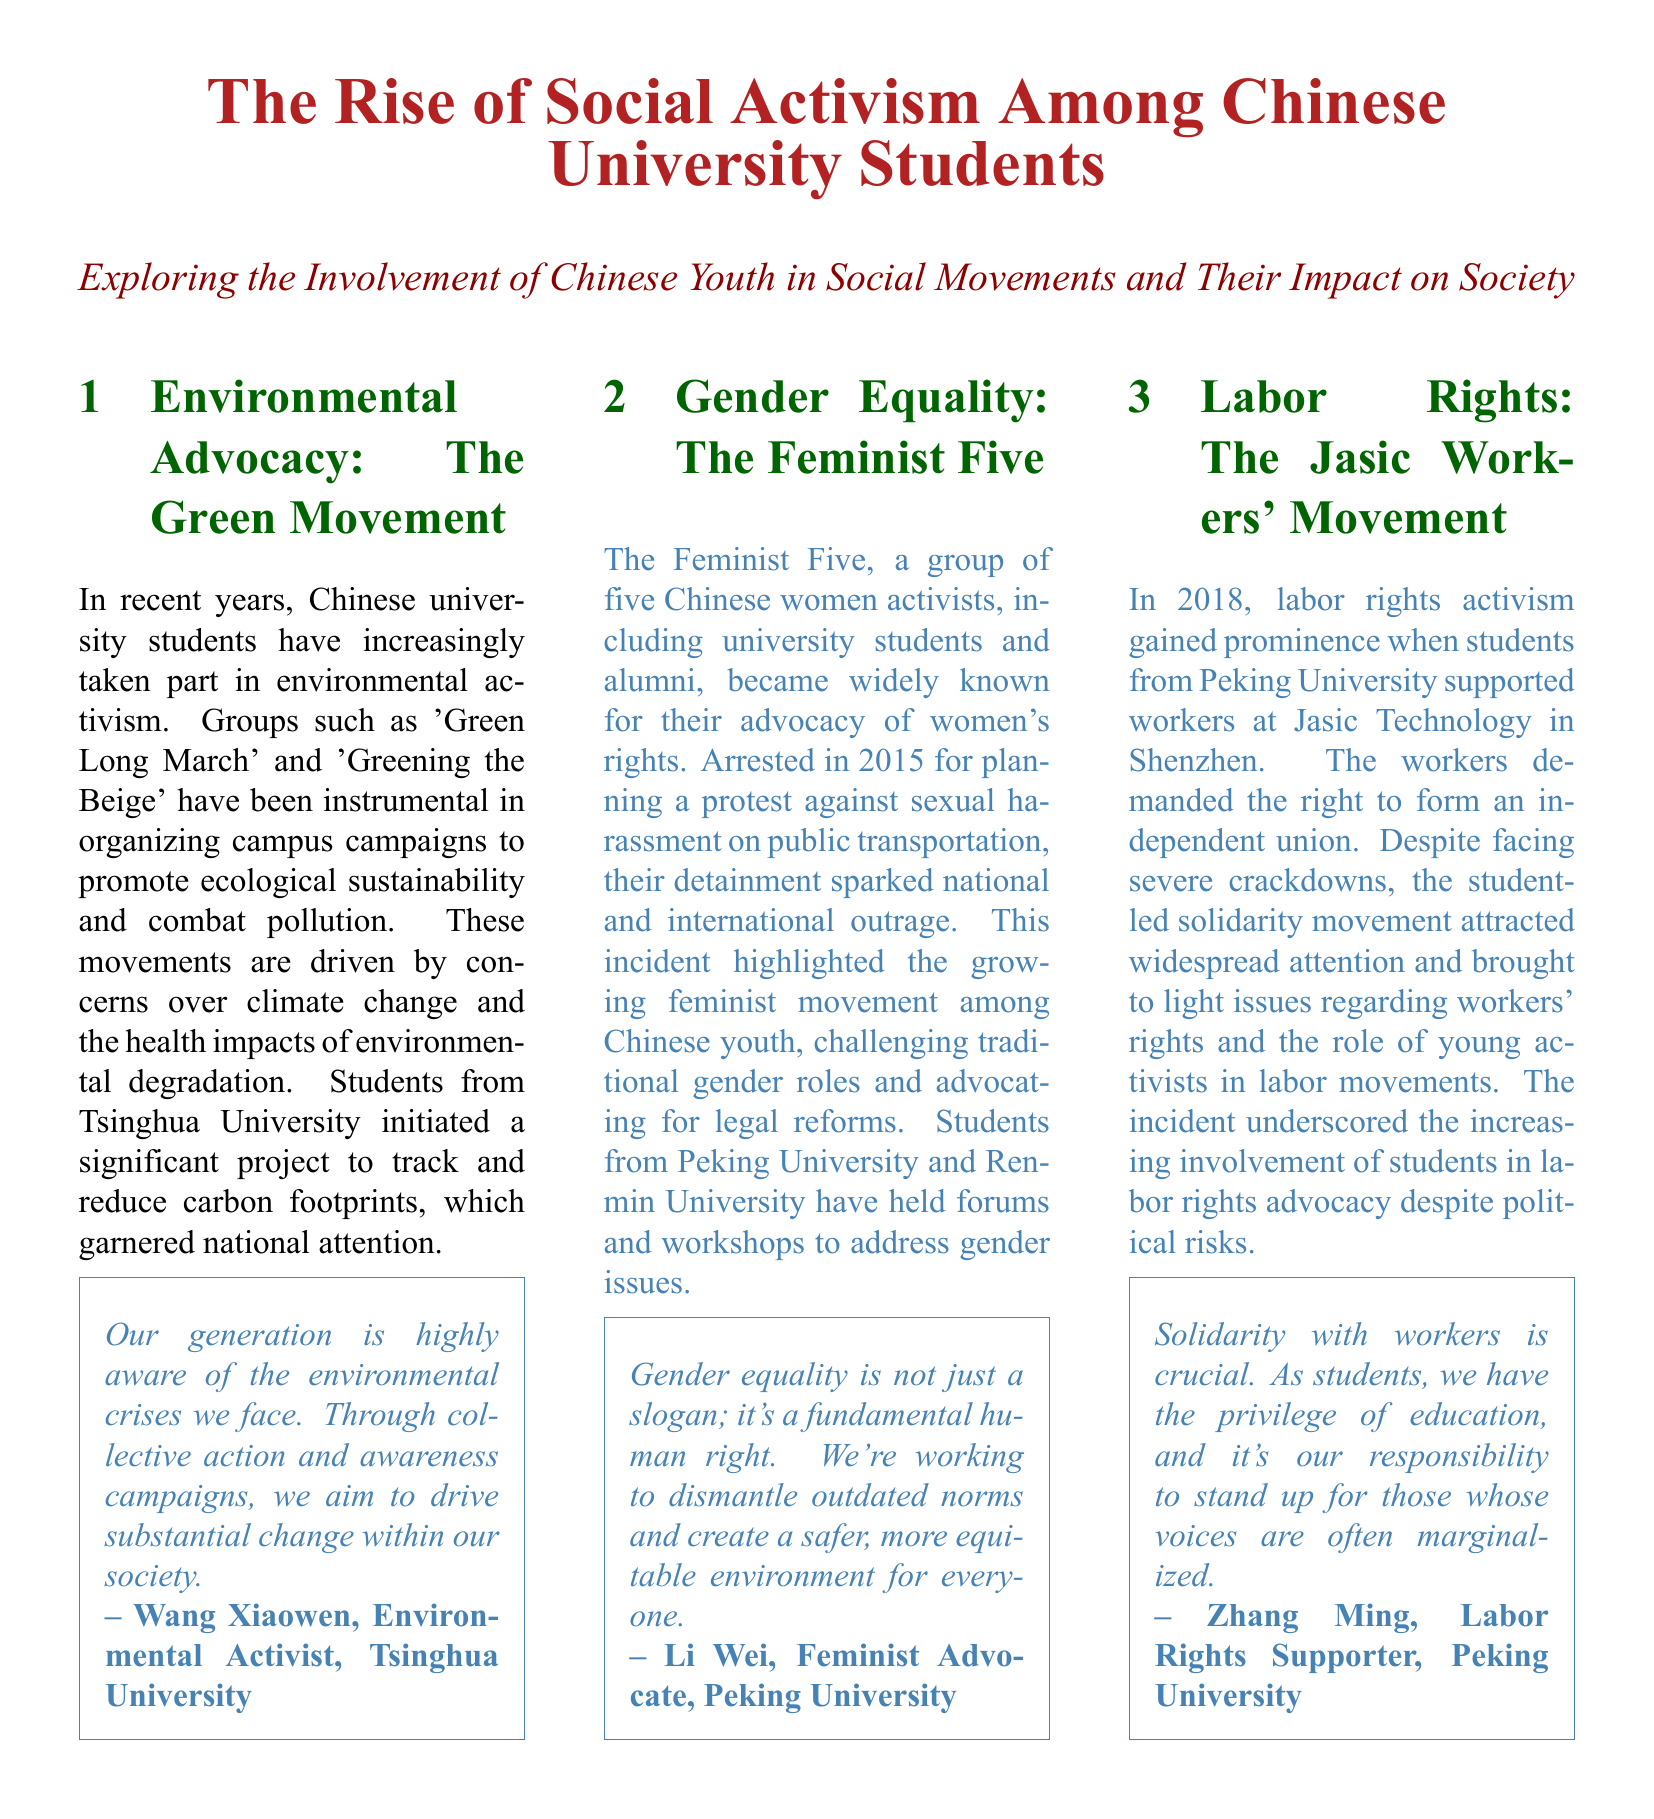What is the name of the environmental advocacy group mentioned? The document highlights 'Green Long March' and 'Greening the Beige' as key groups in environmental activism among students.
Answer: Green Long March Who was arrested in 2015 for advocating women's rights? The document refers to the Feminist Five, a group of five activists involved in women's rights advocacy, who were arrested in 2015.
Answer: The Feminist Five What university did the student-led project to track carbon footprints come from? The initiative to track and reduce carbon footprints was started by students from Tsinghua University, as mentioned in the article.
Answer: Tsinghua University In what year did the Jasic Workers' Movement gain prominence? The document states that the Jasic Workers' Movement gained prominence in 2018 when students supported the workers at Jasic Technology.
Answer: 2018 What underlying issue does the Feminist Five movement address? The Feminist Five's advocacy work primarily addresses gender equality and challenges traditional gender roles in society.
Answer: Gender equality How do Chinese university students view their societal responsibilities regarding activism? Several quotes in the document reflect a belief among students that they have a responsibility to stand up for marginalized voices in society.
Answer: Responsibility Which two universities hosted forums and workshops to address gender issues? According to the document, students from Peking University and Renmin University conducted forums and workshops regarding gender issues.
Answer: Peking University and Renmin University What is the impact of student activism on labor rights according to the document? The document asserts that student-led support has brought attention to workers' rights and raised awareness of labor issues among the public.
Answer: Awareness How does the article illustrate the concept of solidarity among students? The article emphasizes solidarity through student support of workers at Jasic Technology, highlighting their unity in advocating for workers' rights.
Answer: Solidarity 